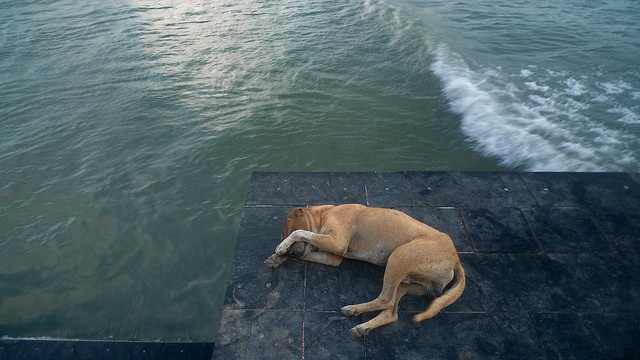Describe the objects in this image and their specific colors. I can see a dog in gray, tan, and black tones in this image. 